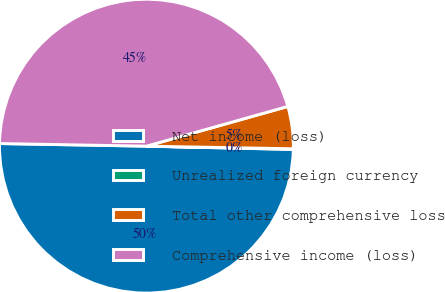Convert chart. <chart><loc_0><loc_0><loc_500><loc_500><pie_chart><fcel>Net income (loss)<fcel>Unrealized foreign currency<fcel>Total other comprehensive loss<fcel>Comprehensive income (loss)<nl><fcel>49.93%<fcel>0.07%<fcel>4.64%<fcel>45.36%<nl></chart> 